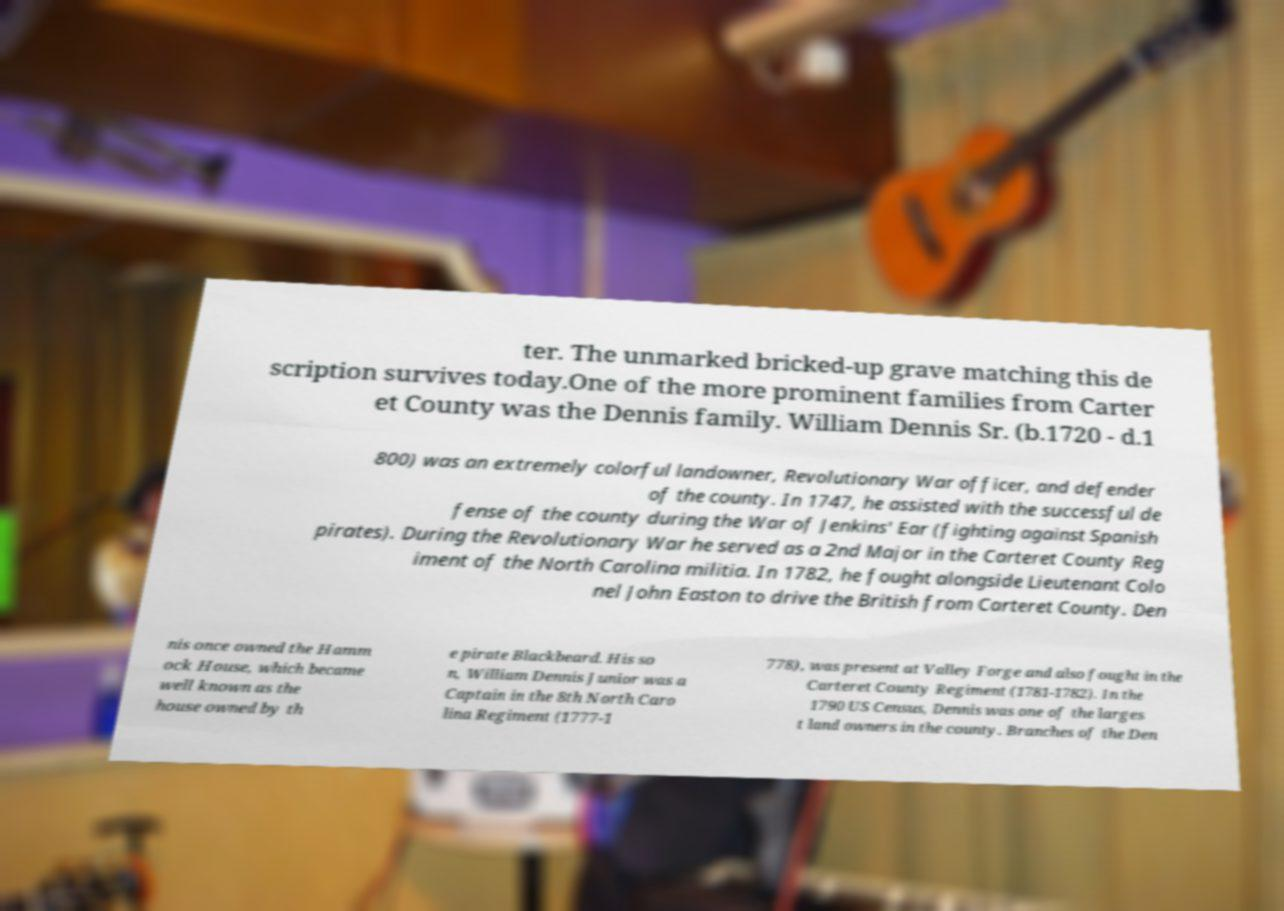Could you assist in decoding the text presented in this image and type it out clearly? ter. The unmarked bricked-up grave matching this de scription survives today.One of the more prominent families from Carter et County was the Dennis family. William Dennis Sr. (b.1720 - d.1 800) was an extremely colorful landowner, Revolutionary War officer, and defender of the county. In 1747, he assisted with the successful de fense of the county during the War of Jenkins' Ear (fighting against Spanish pirates). During the Revolutionary War he served as a 2nd Major in the Carteret County Reg iment of the North Carolina militia. In 1782, he fought alongside Lieutenant Colo nel John Easton to drive the British from Carteret County. Den nis once owned the Hamm ock House, which became well known as the house owned by th e pirate Blackbeard. His so n, William Dennis Junior was a Captain in the 8th North Caro lina Regiment (1777-1 778), was present at Valley Forge and also fought in the Carteret County Regiment (1781-1782). In the 1790 US Census, Dennis was one of the larges t land owners in the county. Branches of the Den 